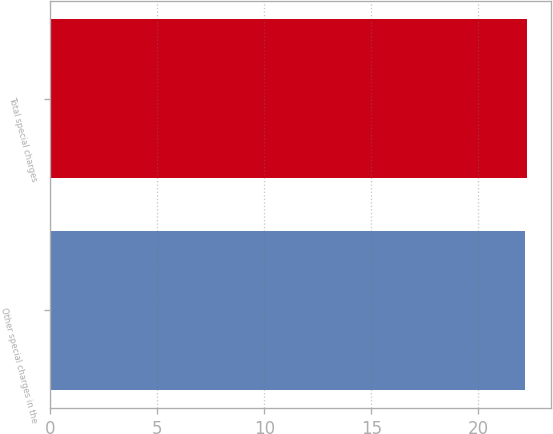<chart> <loc_0><loc_0><loc_500><loc_500><bar_chart><fcel>Other special charges in the<fcel>Total special charges<nl><fcel>22.2<fcel>22.3<nl></chart> 